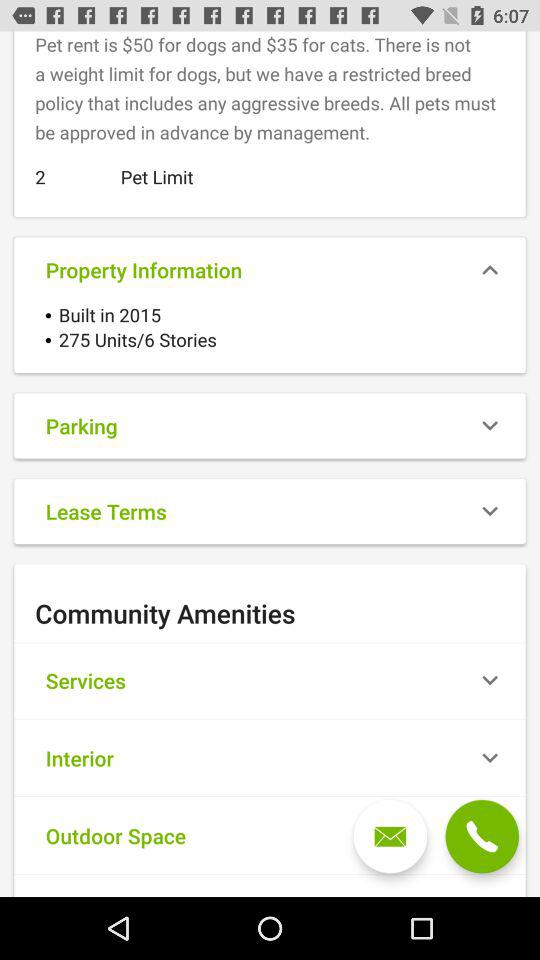How much is the rent for cats? The rent for cats is $35. 